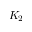<formula> <loc_0><loc_0><loc_500><loc_500>K _ { 2 }</formula> 